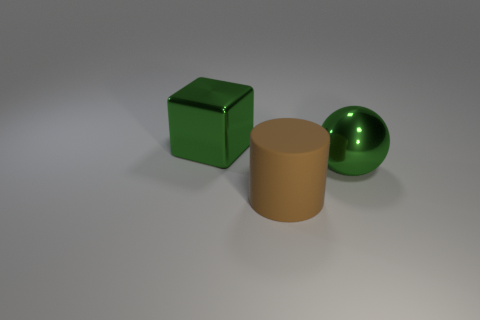Could you describe the lighting in the scene? The lighting in the scene appears to be diffused and ambient, coming from above. There are soft shadows underneath the objects, and the reflections on the sphere and cube suggest there may be a light source above and slightly to the front of them. 